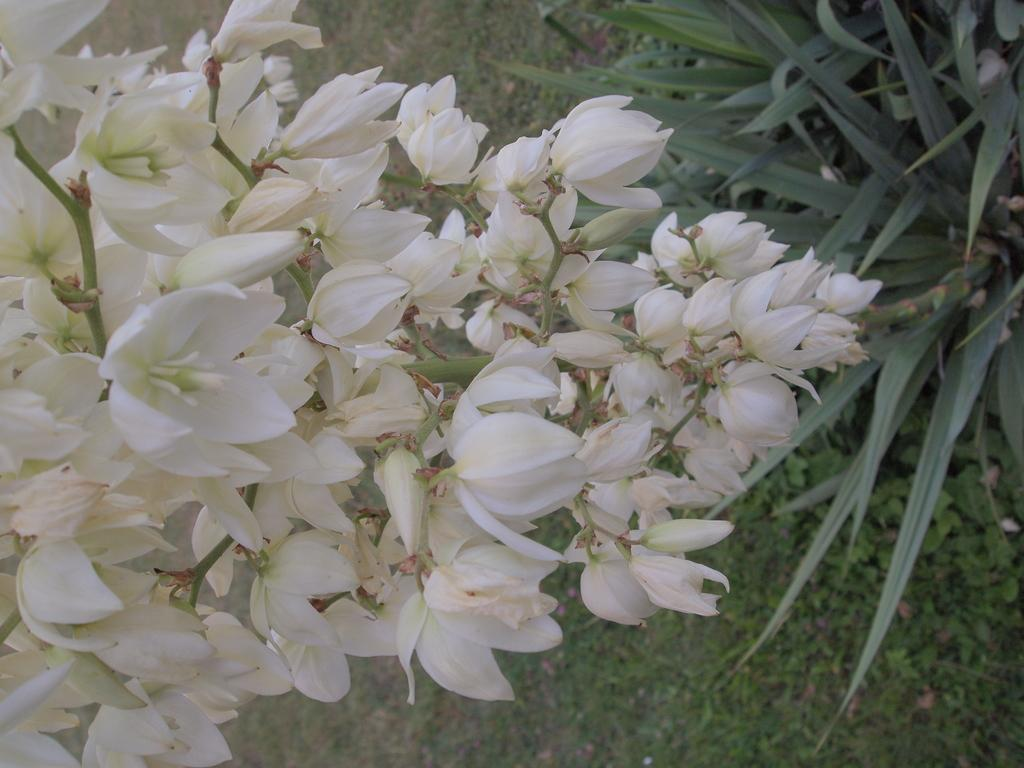What type of flowers can be seen in the image? There are white color flowers in the image. Where are the plants located in the image? The plants are on the right side of the image. What type of vegetation is visible in the background of the image? There is grass visible in the background of the image. What type of teaching method is being used in the image? There is no teaching or educational context present in the image. 